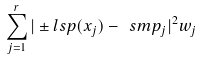Convert formula to latex. <formula><loc_0><loc_0><loc_500><loc_500>\sum _ { j = 1 } ^ { r } | \pm l s p ( x _ { j } ) - \ s m p _ { j } | ^ { 2 } w _ { j }</formula> 